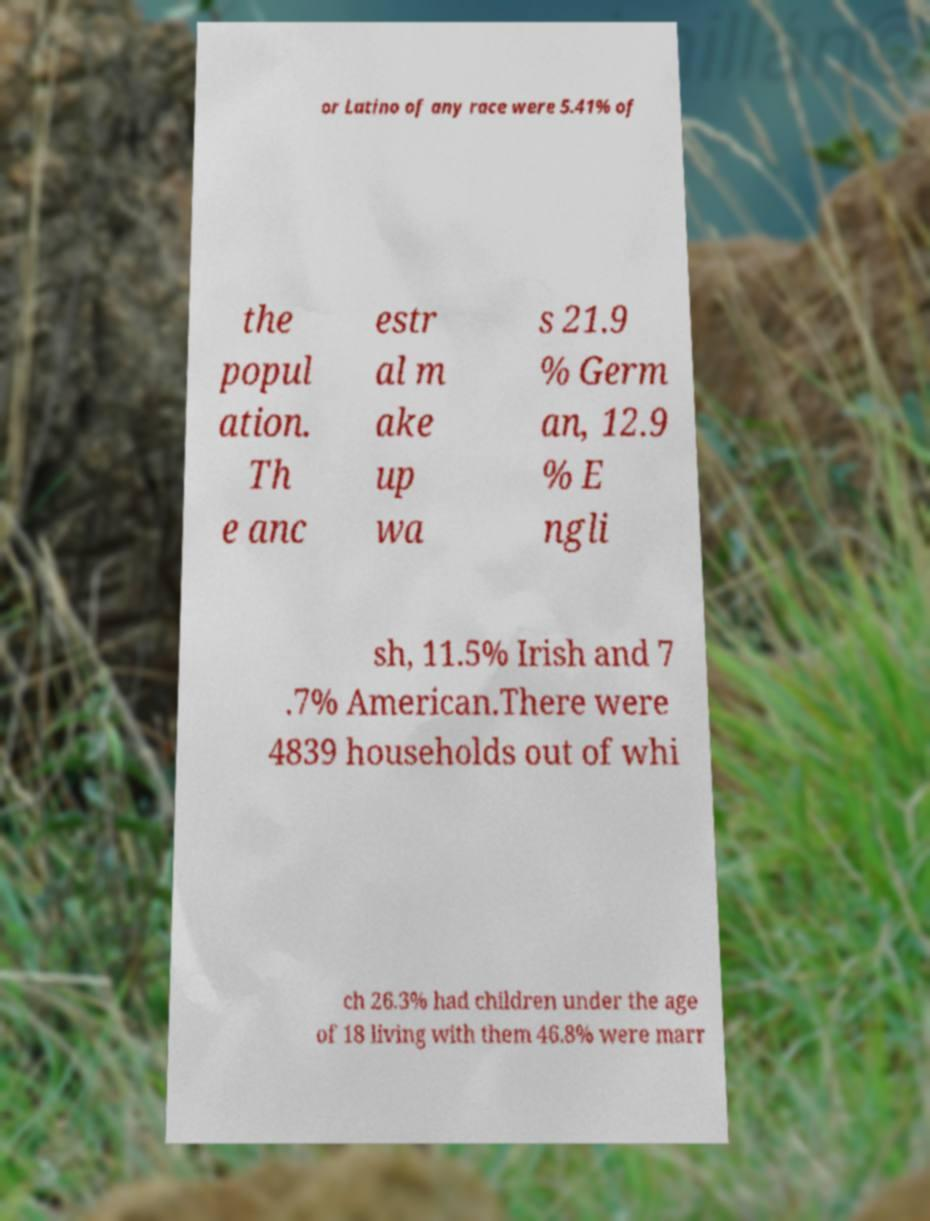There's text embedded in this image that I need extracted. Can you transcribe it verbatim? or Latino of any race were 5.41% of the popul ation. Th e anc estr al m ake up wa s 21.9 % Germ an, 12.9 % E ngli sh, 11.5% Irish and 7 .7% American.There were 4839 households out of whi ch 26.3% had children under the age of 18 living with them 46.8% were marr 